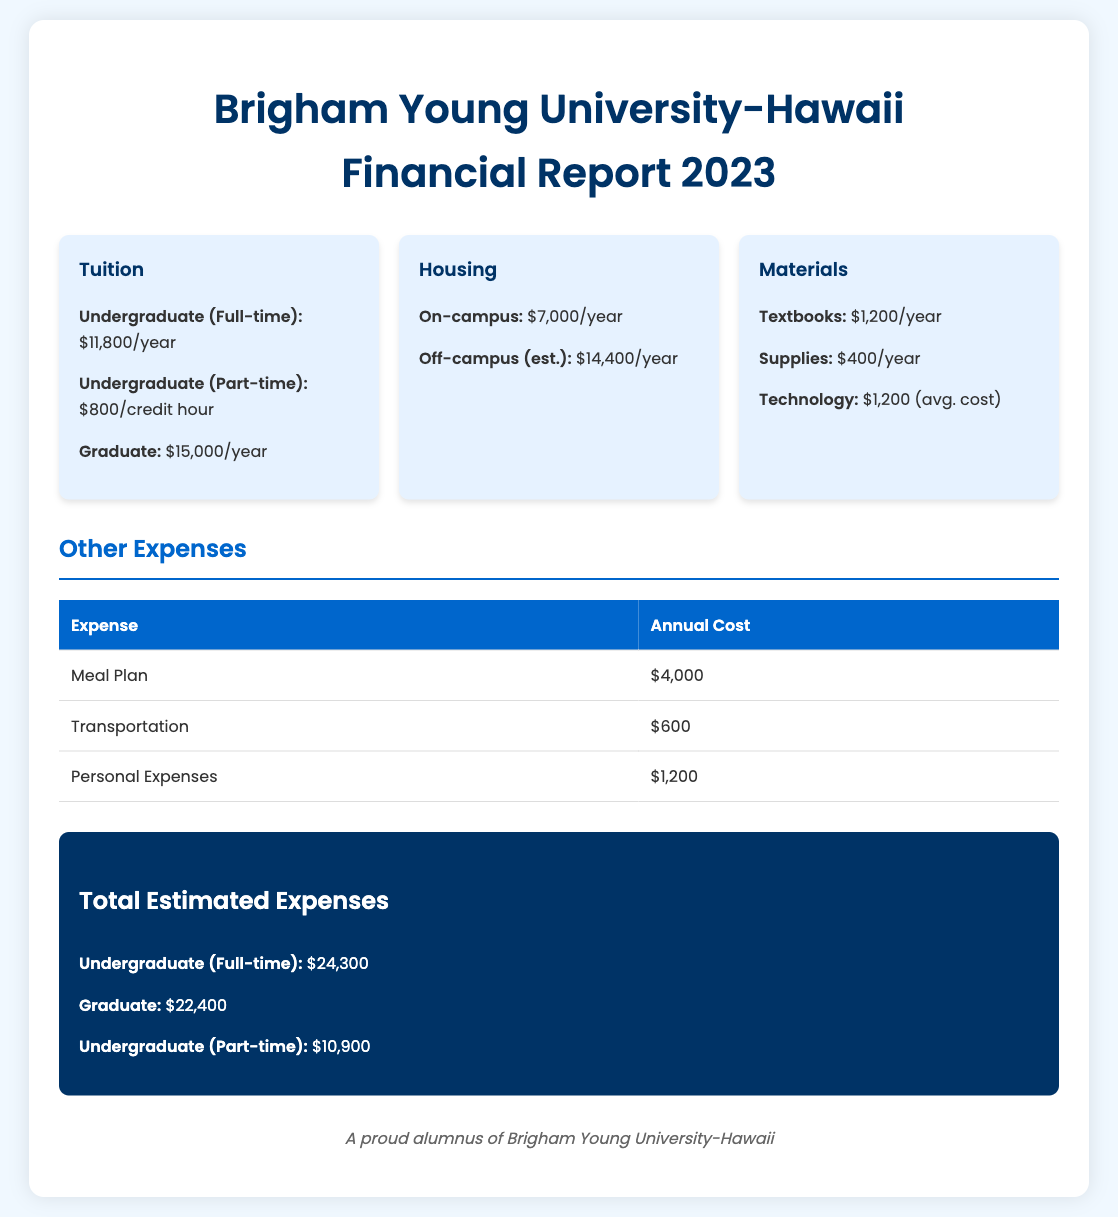what is the tuition for undergraduate full-time students? The document states that the tuition for undergraduate full-time students is $11,800 per year.
Answer: $11,800/year what is the estimated cost for off-campus housing? The report indicates the estimated cost for off-campus housing is $14,400 per year.
Answer: $14,400/year how much are textbooks estimated to cost annually? The document mentions that textbooks cost $1,200 per year.
Answer: $1,200/year what is the total estimated expense for a full-time undergraduate student? The total estimated expense for a full-time undergraduate student is calculated as $24,300 in the report.
Answer: $24,300 how much is the meal plan cost? The meal plan cost is detailed as $4,000 in the document.
Answer: $4,000 what is the average cost for technology expenses? The average cost for technology is listed as $1,200 in the financial report.
Answer: $1,200 what is the annual cost of personal expenses? The report specifies that personal expenses cost $1,200 per year.
Answer: $1,200 what is the housing cost for on-campus living? The document states that the housing cost for on-campus living is $7,000 per year.
Answer: $7,000/year what type of document is this? This document is a financial report detailing educational expenses.
Answer: financial report 